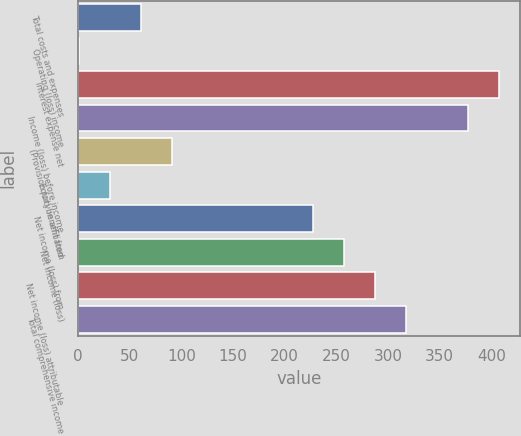Convert chart to OTSL. <chart><loc_0><loc_0><loc_500><loc_500><bar_chart><fcel>Total costs and expenses<fcel>Operating (loss) income<fcel>Interest expense net<fcel>Income (loss) before income<fcel>(Provision for) benefit from<fcel>Equity in affiliated<fcel>Net income (loss) from<fcel>Net income (loss)<fcel>Net income (loss) attributable<fcel>Total comprehensive income<nl><fcel>61<fcel>1<fcel>407<fcel>377<fcel>91<fcel>31<fcel>227<fcel>257<fcel>287<fcel>317<nl></chart> 